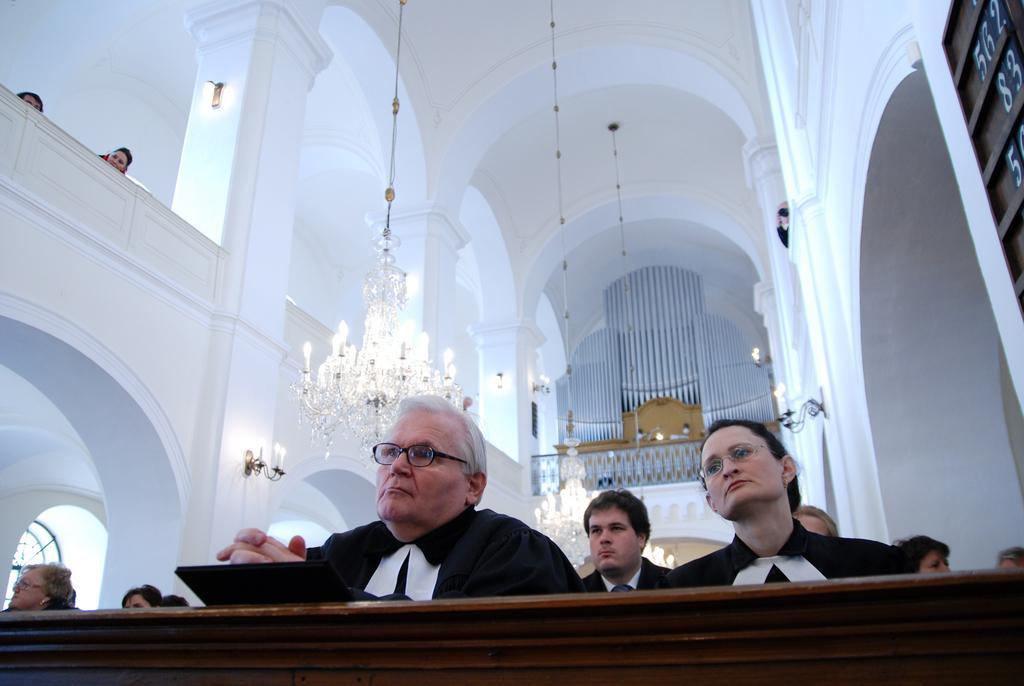Could you give a brief overview of what you see in this image? At the bottom of the image there is a table. Behind the table there are few people. In the background there are walls, pillars, lamps, arches and chandeliers. In the top right corner of the image there is a board with numbers. 